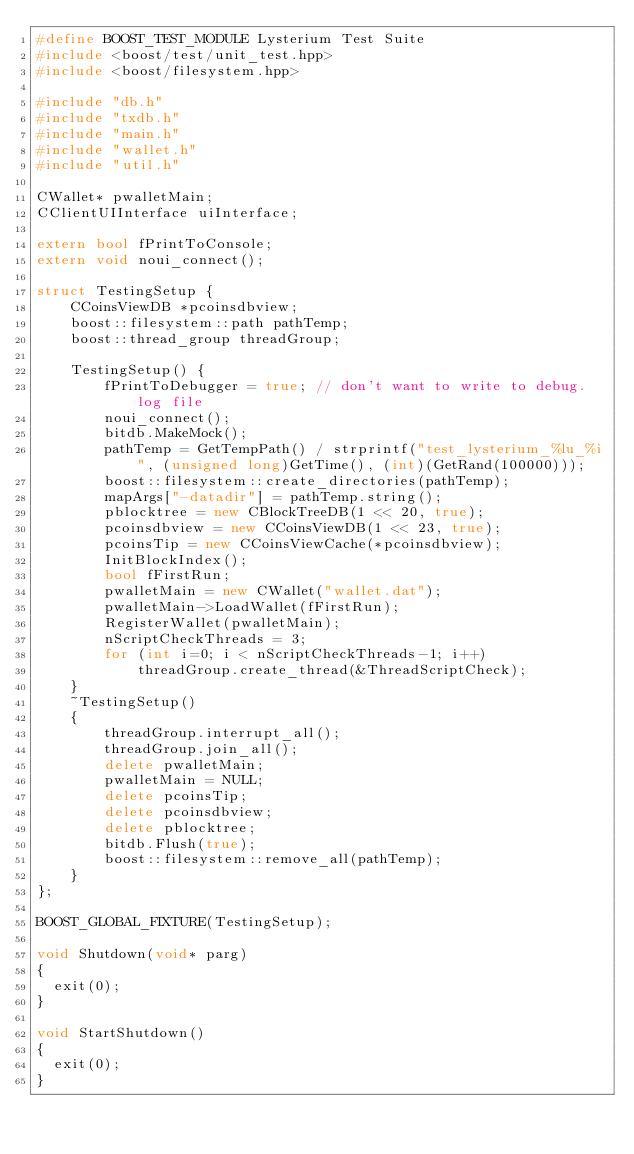<code> <loc_0><loc_0><loc_500><loc_500><_C++_>#define BOOST_TEST_MODULE Lysterium Test Suite
#include <boost/test/unit_test.hpp>
#include <boost/filesystem.hpp>

#include "db.h"
#include "txdb.h"
#include "main.h"
#include "wallet.h"
#include "util.h"

CWallet* pwalletMain;
CClientUIInterface uiInterface;

extern bool fPrintToConsole;
extern void noui_connect();

struct TestingSetup {
    CCoinsViewDB *pcoinsdbview;
    boost::filesystem::path pathTemp;
    boost::thread_group threadGroup;

    TestingSetup() {
        fPrintToDebugger = true; // don't want to write to debug.log file
        noui_connect();
        bitdb.MakeMock();
        pathTemp = GetTempPath() / strprintf("test_lysterium_%lu_%i", (unsigned long)GetTime(), (int)(GetRand(100000)));
        boost::filesystem::create_directories(pathTemp);
        mapArgs["-datadir"] = pathTemp.string();
        pblocktree = new CBlockTreeDB(1 << 20, true);
        pcoinsdbview = new CCoinsViewDB(1 << 23, true);
        pcoinsTip = new CCoinsViewCache(*pcoinsdbview);
        InitBlockIndex();
        bool fFirstRun;
        pwalletMain = new CWallet("wallet.dat");
        pwalletMain->LoadWallet(fFirstRun);
        RegisterWallet(pwalletMain);
        nScriptCheckThreads = 3;
        for (int i=0; i < nScriptCheckThreads-1; i++)
            threadGroup.create_thread(&ThreadScriptCheck);
    }
    ~TestingSetup()
    {
        threadGroup.interrupt_all();
        threadGroup.join_all();
        delete pwalletMain;
        pwalletMain = NULL;
        delete pcoinsTip;
        delete pcoinsdbview;
        delete pblocktree;
        bitdb.Flush(true);
        boost::filesystem::remove_all(pathTemp);
    }
};

BOOST_GLOBAL_FIXTURE(TestingSetup);

void Shutdown(void* parg)
{
  exit(0);
}

void StartShutdown()
{
  exit(0);
}

</code> 